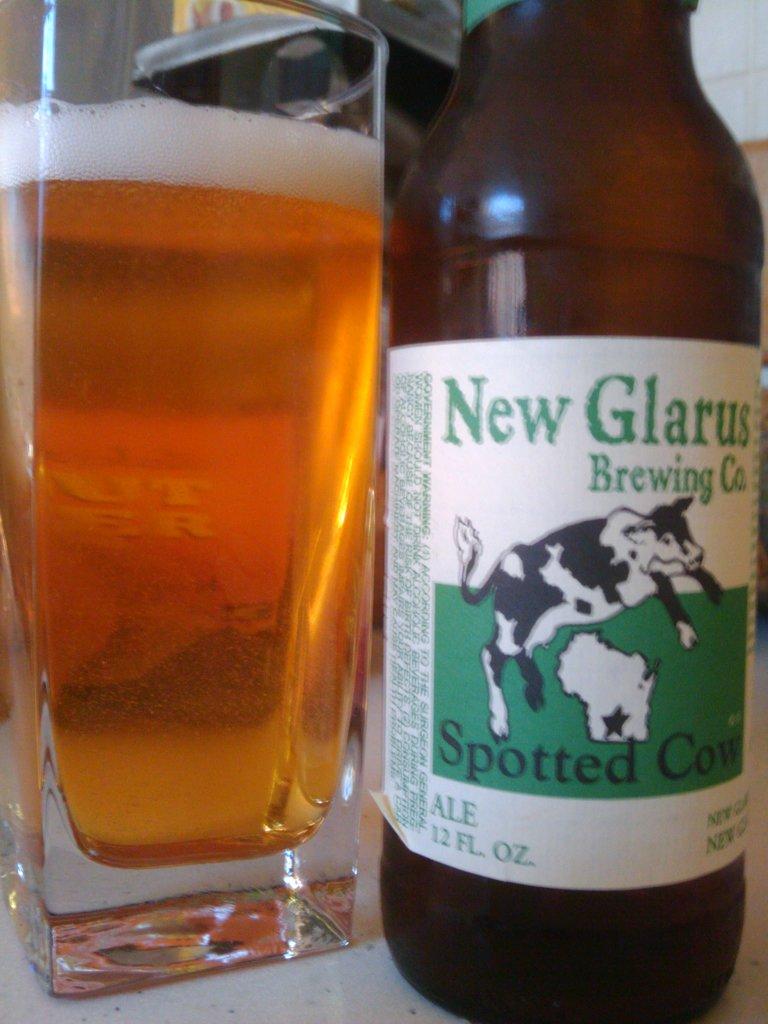What is the brand on the bottle?
Provide a short and direct response. New glarus brewing co. 